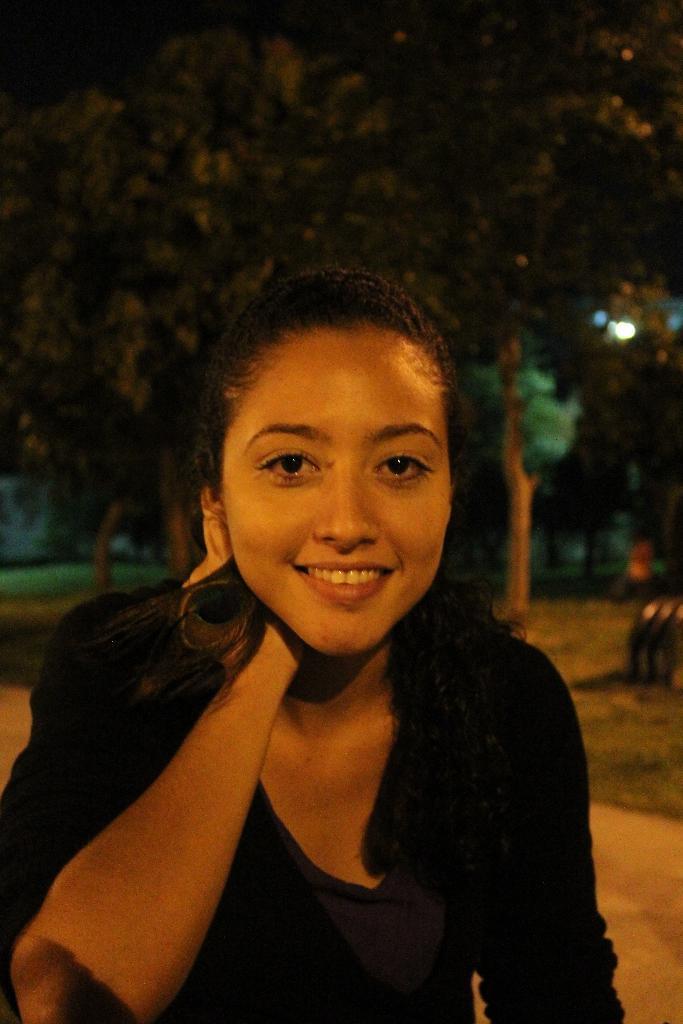Could you give a brief overview of what you see in this image? In this image we can see a woman. And in the background, we can see the trees and lights. 